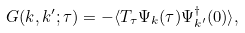Convert formula to latex. <formula><loc_0><loc_0><loc_500><loc_500>G ( { k } , { k } ^ { \prime } ; \tau ) = - \langle T _ { \tau } \Psi _ { k } ( \tau ) \Psi ^ { \dagger } _ { { k } ^ { \prime } } ( 0 ) \rangle ,</formula> 